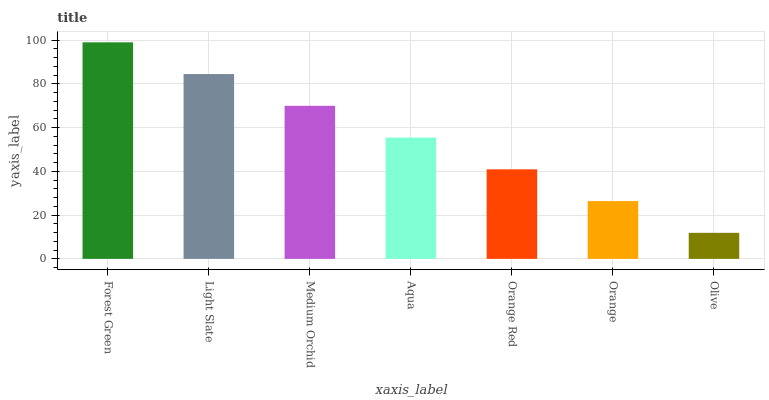Is Light Slate the minimum?
Answer yes or no. No. Is Light Slate the maximum?
Answer yes or no. No. Is Forest Green greater than Light Slate?
Answer yes or no. Yes. Is Light Slate less than Forest Green?
Answer yes or no. Yes. Is Light Slate greater than Forest Green?
Answer yes or no. No. Is Forest Green less than Light Slate?
Answer yes or no. No. Is Aqua the high median?
Answer yes or no. Yes. Is Aqua the low median?
Answer yes or no. Yes. Is Olive the high median?
Answer yes or no. No. Is Forest Green the low median?
Answer yes or no. No. 